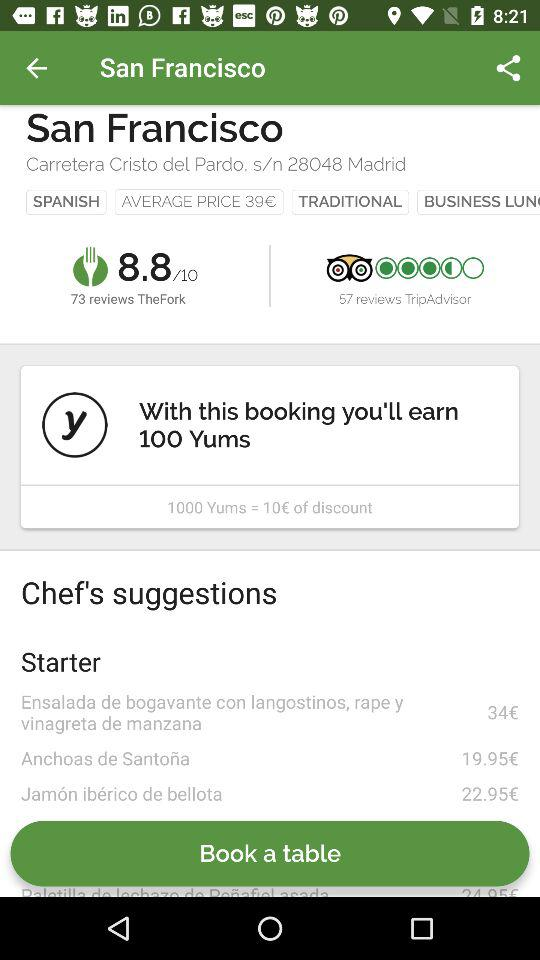How many reviews does this restaurant have on TripAdvisor?
Answer the question using a single word or phrase. 57 